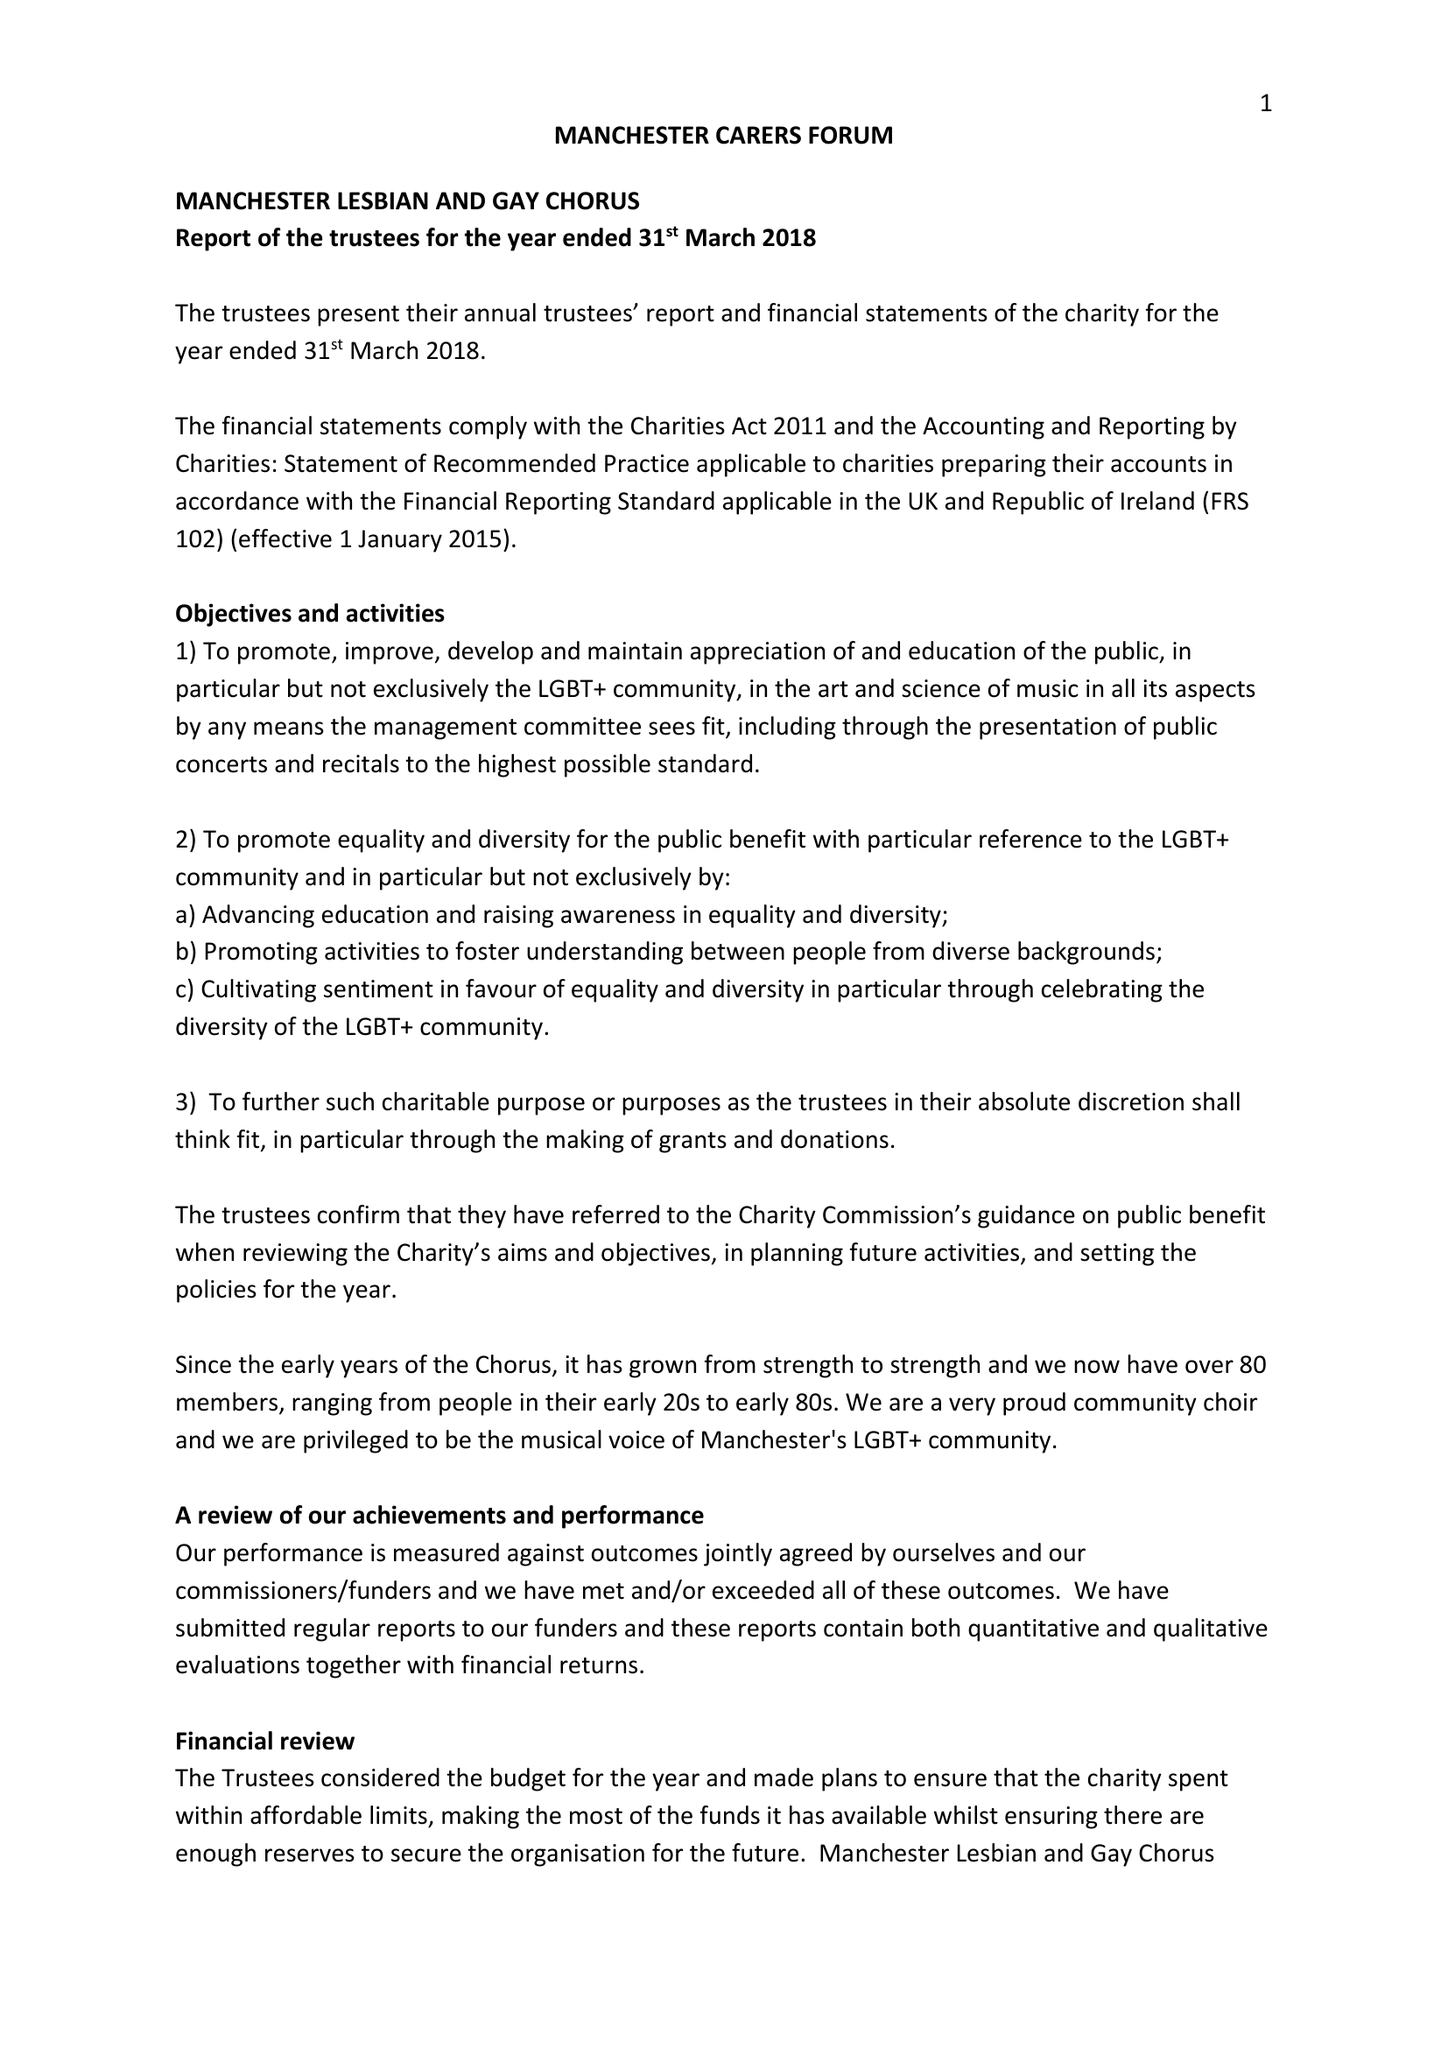What is the value for the income_annually_in_british_pounds?
Answer the question using a single word or phrase. 20737.00 